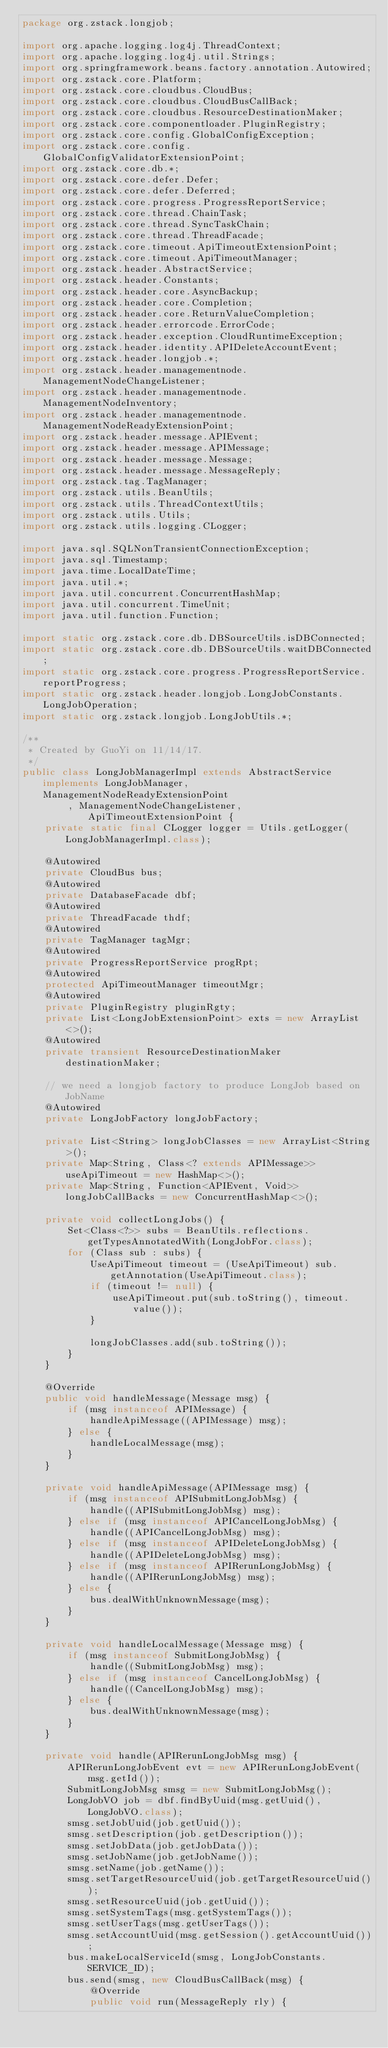Convert code to text. <code><loc_0><loc_0><loc_500><loc_500><_Java_>package org.zstack.longjob;

import org.apache.logging.log4j.ThreadContext;
import org.apache.logging.log4j.util.Strings;
import org.springframework.beans.factory.annotation.Autowired;
import org.zstack.core.Platform;
import org.zstack.core.cloudbus.CloudBus;
import org.zstack.core.cloudbus.CloudBusCallBack;
import org.zstack.core.cloudbus.ResourceDestinationMaker;
import org.zstack.core.componentloader.PluginRegistry;
import org.zstack.core.config.GlobalConfigException;
import org.zstack.core.config.GlobalConfigValidatorExtensionPoint;
import org.zstack.core.db.*;
import org.zstack.core.defer.Defer;
import org.zstack.core.defer.Deferred;
import org.zstack.core.progress.ProgressReportService;
import org.zstack.core.thread.ChainTask;
import org.zstack.core.thread.SyncTaskChain;
import org.zstack.core.thread.ThreadFacade;
import org.zstack.core.timeout.ApiTimeoutExtensionPoint;
import org.zstack.core.timeout.ApiTimeoutManager;
import org.zstack.header.AbstractService;
import org.zstack.header.Constants;
import org.zstack.header.core.AsyncBackup;
import org.zstack.header.core.Completion;
import org.zstack.header.core.ReturnValueCompletion;
import org.zstack.header.errorcode.ErrorCode;
import org.zstack.header.exception.CloudRuntimeException;
import org.zstack.header.identity.APIDeleteAccountEvent;
import org.zstack.header.longjob.*;
import org.zstack.header.managementnode.ManagementNodeChangeListener;
import org.zstack.header.managementnode.ManagementNodeInventory;
import org.zstack.header.managementnode.ManagementNodeReadyExtensionPoint;
import org.zstack.header.message.APIEvent;
import org.zstack.header.message.APIMessage;
import org.zstack.header.message.Message;
import org.zstack.header.message.MessageReply;
import org.zstack.tag.TagManager;
import org.zstack.utils.BeanUtils;
import org.zstack.utils.ThreadContextUtils;
import org.zstack.utils.Utils;
import org.zstack.utils.logging.CLogger;

import java.sql.SQLNonTransientConnectionException;
import java.sql.Timestamp;
import java.time.LocalDateTime;
import java.util.*;
import java.util.concurrent.ConcurrentHashMap;
import java.util.concurrent.TimeUnit;
import java.util.function.Function;

import static org.zstack.core.db.DBSourceUtils.isDBConnected;
import static org.zstack.core.db.DBSourceUtils.waitDBConnected;
import static org.zstack.core.progress.ProgressReportService.reportProgress;
import static org.zstack.header.longjob.LongJobConstants.LongJobOperation;
import static org.zstack.longjob.LongJobUtils.*;

/**
 * Created by GuoYi on 11/14/17.
 */
public class LongJobManagerImpl extends AbstractService implements LongJobManager, ManagementNodeReadyExtensionPoint
        , ManagementNodeChangeListener, ApiTimeoutExtensionPoint {
    private static final CLogger logger = Utils.getLogger(LongJobManagerImpl.class);

    @Autowired
    private CloudBus bus;
    @Autowired
    private DatabaseFacade dbf;
    @Autowired
    private ThreadFacade thdf;
    @Autowired
    private TagManager tagMgr;
    @Autowired
    private ProgressReportService progRpt;
    @Autowired
    protected ApiTimeoutManager timeoutMgr;
    @Autowired
    private PluginRegistry pluginRgty;
    private List<LongJobExtensionPoint> exts = new ArrayList<>();
    @Autowired
    private transient ResourceDestinationMaker destinationMaker;

    // we need a longjob factory to produce LongJob based on JobName
    @Autowired
    private LongJobFactory longJobFactory;

    private List<String> longJobClasses = new ArrayList<String>();
    private Map<String, Class<? extends APIMessage>> useApiTimeout = new HashMap<>();
    private Map<String, Function<APIEvent, Void>> longJobCallBacks = new ConcurrentHashMap<>();

    private void collectLongJobs() {
        Set<Class<?>> subs = BeanUtils.reflections.getTypesAnnotatedWith(LongJobFor.class);
        for (Class sub : subs) {
            UseApiTimeout timeout = (UseApiTimeout) sub.getAnnotation(UseApiTimeout.class);
            if (timeout != null) {
                useApiTimeout.put(sub.toString(), timeout.value());
            }

            longJobClasses.add(sub.toString());
        }
    }

    @Override
    public void handleMessage(Message msg) {
        if (msg instanceof APIMessage) {
            handleApiMessage((APIMessage) msg);
        } else {
            handleLocalMessage(msg);
        }
    }

    private void handleApiMessage(APIMessage msg) {
        if (msg instanceof APISubmitLongJobMsg) {
            handle((APISubmitLongJobMsg) msg);
        } else if (msg instanceof APICancelLongJobMsg) {
            handle((APICancelLongJobMsg) msg);
        } else if (msg instanceof APIDeleteLongJobMsg) {
            handle((APIDeleteLongJobMsg) msg);
        } else if (msg instanceof APIRerunLongJobMsg) {
            handle((APIRerunLongJobMsg) msg);
        } else {
            bus.dealWithUnknownMessage(msg);
        }
    }

    private void handleLocalMessage(Message msg) {
        if (msg instanceof SubmitLongJobMsg) {
            handle((SubmitLongJobMsg) msg);
        } else if (msg instanceof CancelLongJobMsg) {
            handle((CancelLongJobMsg) msg);
        } else {
            bus.dealWithUnknownMessage(msg);
        }
    }

    private void handle(APIRerunLongJobMsg msg) {
        APIRerunLongJobEvent evt = new APIRerunLongJobEvent(msg.getId());
        SubmitLongJobMsg smsg = new SubmitLongJobMsg();
        LongJobVO job = dbf.findByUuid(msg.getUuid(), LongJobVO.class);
        smsg.setJobUuid(job.getUuid());
        smsg.setDescription(job.getDescription());
        smsg.setJobData(job.getJobData());
        smsg.setJobName(job.getJobName());
        smsg.setName(job.getName());
        smsg.setTargetResourceUuid(job.getTargetResourceUuid());
        smsg.setResourceUuid(job.getUuid());
        smsg.setSystemTags(msg.getSystemTags());
        smsg.setUserTags(msg.getUserTags());
        smsg.setAccountUuid(msg.getSession().getAccountUuid());
        bus.makeLocalServiceId(smsg, LongJobConstants.SERVICE_ID);
        bus.send(smsg, new CloudBusCallBack(msg) {
            @Override
            public void run(MessageReply rly) {</code> 